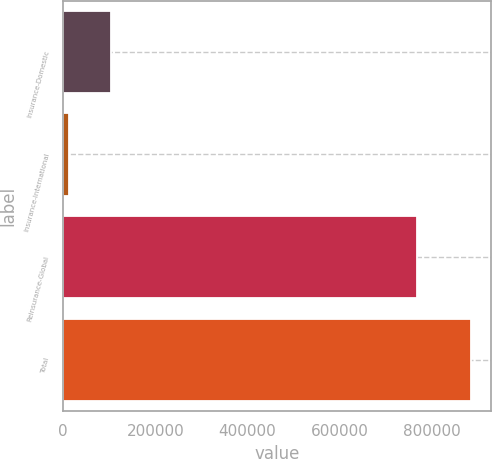Convert chart. <chart><loc_0><loc_0><loc_500><loc_500><bar_chart><fcel>Insurance-Domestic<fcel>Insurance-International<fcel>Reinsurance-Global<fcel>Total<nl><fcel>104407<fcel>11749<fcel>768763<fcel>884919<nl></chart> 